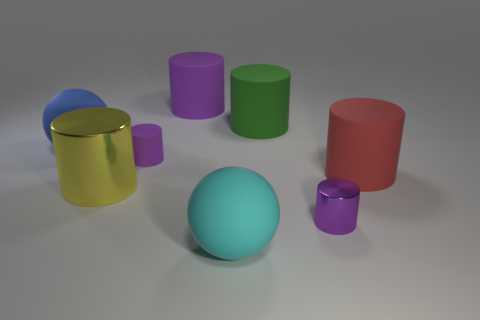What could be the purpose of the arrangement of these objects? The arrangement seems to be non-functional and purely aesthetic, as if designed for an art installation or a graphic rendering showcase. The objects might represent a study of colors and shapes, possibly meant to observe reflections, contrasts, or spatial composition. 